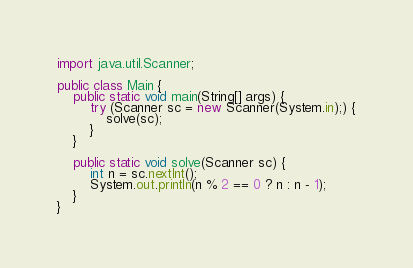Convert code to text. <code><loc_0><loc_0><loc_500><loc_500><_Java_>import java.util.Scanner;

public class Main {
    public static void main(String[] args) {
        try (Scanner sc = new Scanner(System.in);) {
            solve(sc);
        }
    }

    public static void solve(Scanner sc) {
        int n = sc.nextInt();
        System.out.println(n % 2 == 0 ? n : n - 1);
    }
}</code> 